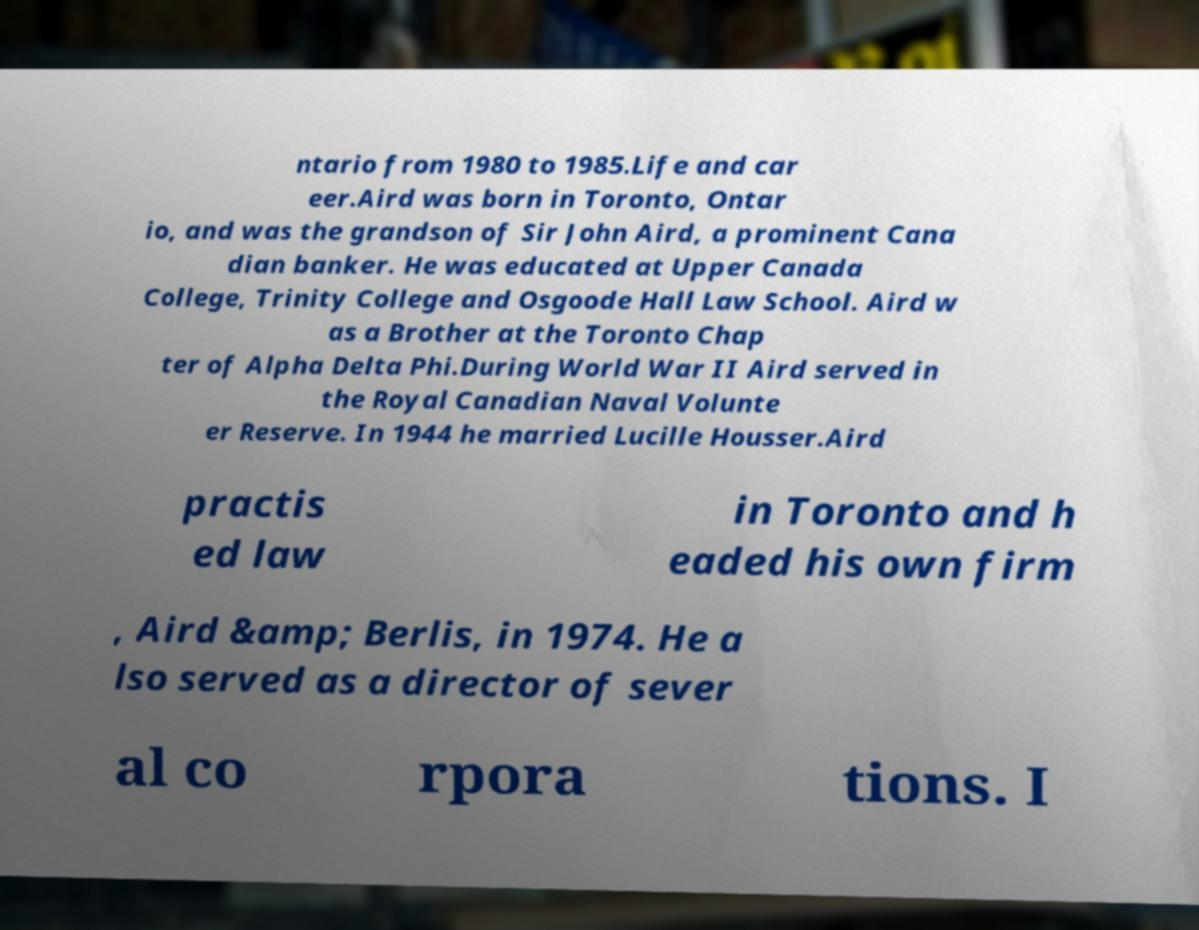Can you read and provide the text displayed in the image?This photo seems to have some interesting text. Can you extract and type it out for me? ntario from 1980 to 1985.Life and car eer.Aird was born in Toronto, Ontar io, and was the grandson of Sir John Aird, a prominent Cana dian banker. He was educated at Upper Canada College, Trinity College and Osgoode Hall Law School. Aird w as a Brother at the Toronto Chap ter of Alpha Delta Phi.During World War II Aird served in the Royal Canadian Naval Volunte er Reserve. In 1944 he married Lucille Housser.Aird practis ed law in Toronto and h eaded his own firm , Aird &amp; Berlis, in 1974. He a lso served as a director of sever al co rpora tions. I 